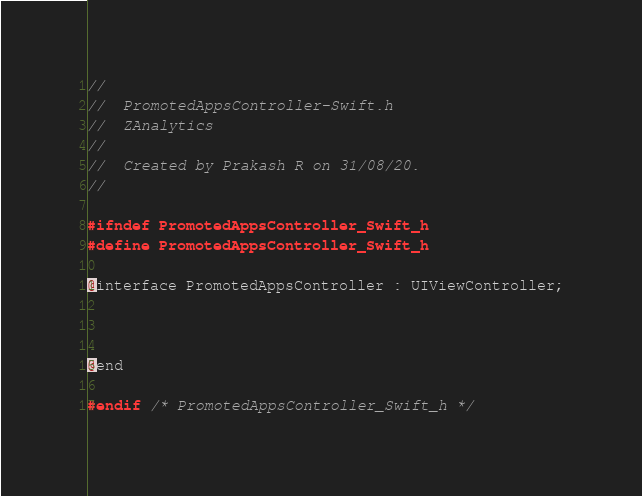Convert code to text. <code><loc_0><loc_0><loc_500><loc_500><_C_>//
//  PromotedAppsController-Swift.h
//  ZAnalytics
//
//  Created by Prakash R on 31/08/20.
//

#ifndef PromotedAppsController_Swift_h
#define PromotedAppsController_Swift_h

@interface PromotedAppsController : UIViewController;



@end

#endif /* PromotedAppsController_Swift_h */
</code> 